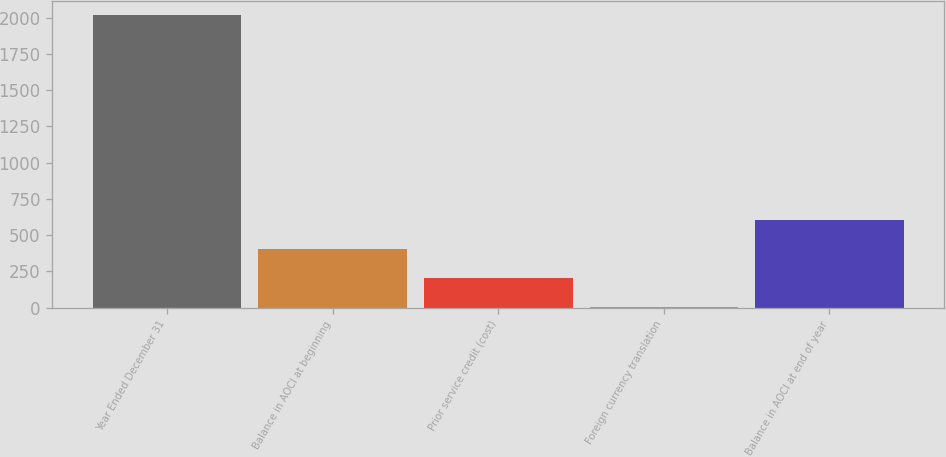Convert chart to OTSL. <chart><loc_0><loc_0><loc_500><loc_500><bar_chart><fcel>Year Ended December 31<fcel>Balance in AOCI at beginning<fcel>Prior service credit (cost)<fcel>Foreign currency translation<fcel>Balance in AOCI at end of year<nl><fcel>2016<fcel>404<fcel>202.5<fcel>1<fcel>605.5<nl></chart> 